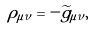<formula> <loc_0><loc_0><loc_500><loc_500>\rho _ { \mu \nu } = - { \widetilde { g } } _ { \mu \nu } ,</formula> 